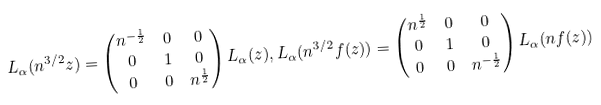<formula> <loc_0><loc_0><loc_500><loc_500>L _ { \alpha } ( n ^ { 3 / 2 } z ) & = \begin{pmatrix} n ^ { - \frac { 1 } { 2 } } & 0 & 0 \\ 0 & 1 & 0 \\ 0 & 0 & n ^ { \frac { 1 } { 2 } } \end{pmatrix} L _ { \alpha } ( z ) , L _ { \alpha } ( n ^ { 3 / 2 } f ( z ) ) = \begin{pmatrix} n ^ { \frac { 1 } { 2 } } & 0 & 0 \\ 0 & 1 & 0 \\ 0 & 0 & n ^ { - \frac { 1 } { 2 } } \end{pmatrix} L _ { \alpha } ( n f ( z ) )</formula> 